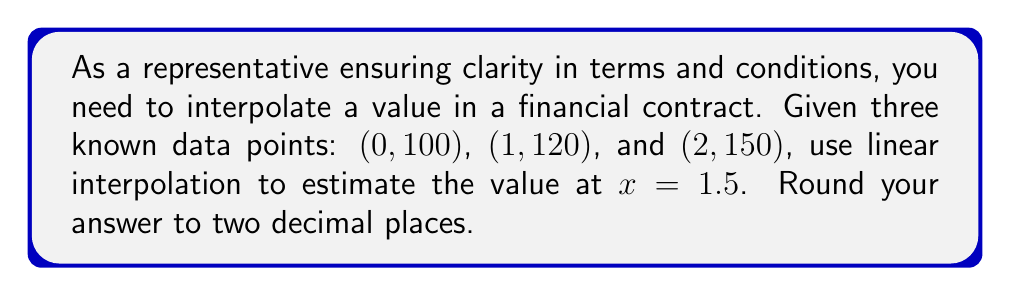Teach me how to tackle this problem. To solve this problem using linear interpolation, we'll follow these steps:

1) Linear interpolation uses the formula:
   $$y = y_1 + \frac{(x - x_1)(y_2 - y_1)}{(x_2 - x_1)}$$
   where $(x_1, y_1)$ and $(x_2, y_2)$ are known points, and $(x, y)$ is the point we're interpolating.

2) We need to choose the two known points that surround our desired $x$ value of 1.5. These are $(1, 120)$ and $(2, 150)$.

3) Let's assign our variables:
   $x_1 = 1$, $y_1 = 120$
   $x_2 = 2$, $y_2 = 150$
   $x = 1.5$

4) Now, let's substitute these into our formula:

   $$y = 120 + \frac{(1.5 - 1)(150 - 120)}{(2 - 1)}$$

5) Simplify:
   $$y = 120 + \frac{(0.5)(30)}{1}$$
   $$y = 120 + 15$$
   $$y = 135$$

6) Rounding to two decimal places:
   $$y \approx 135.00$$
Answer: $135.00$ 